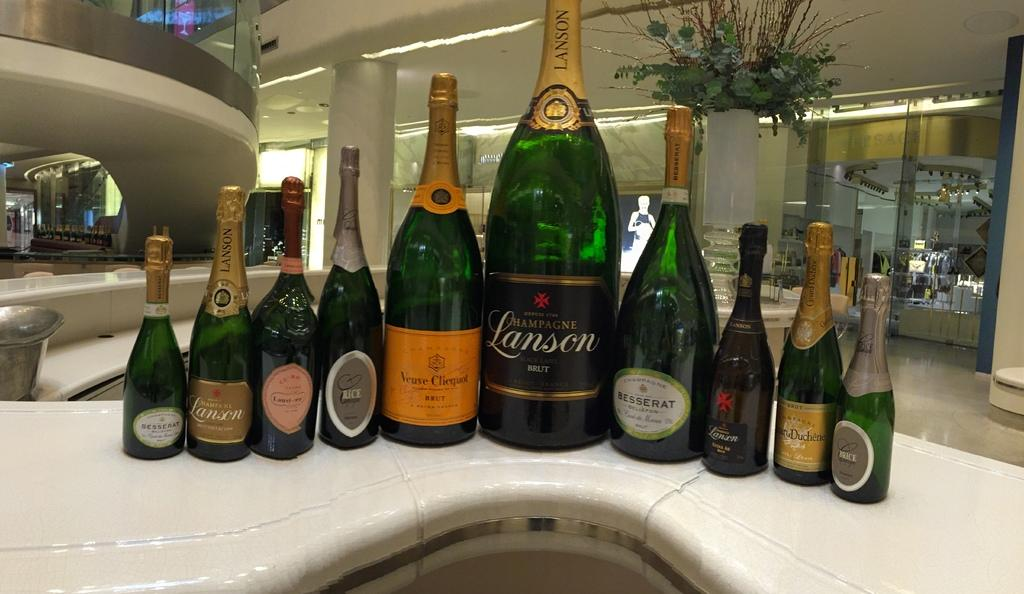Provide a one-sentence caption for the provided image. Lansen Champagne, Brice Champagne, and Besserat Champagne on a table. 